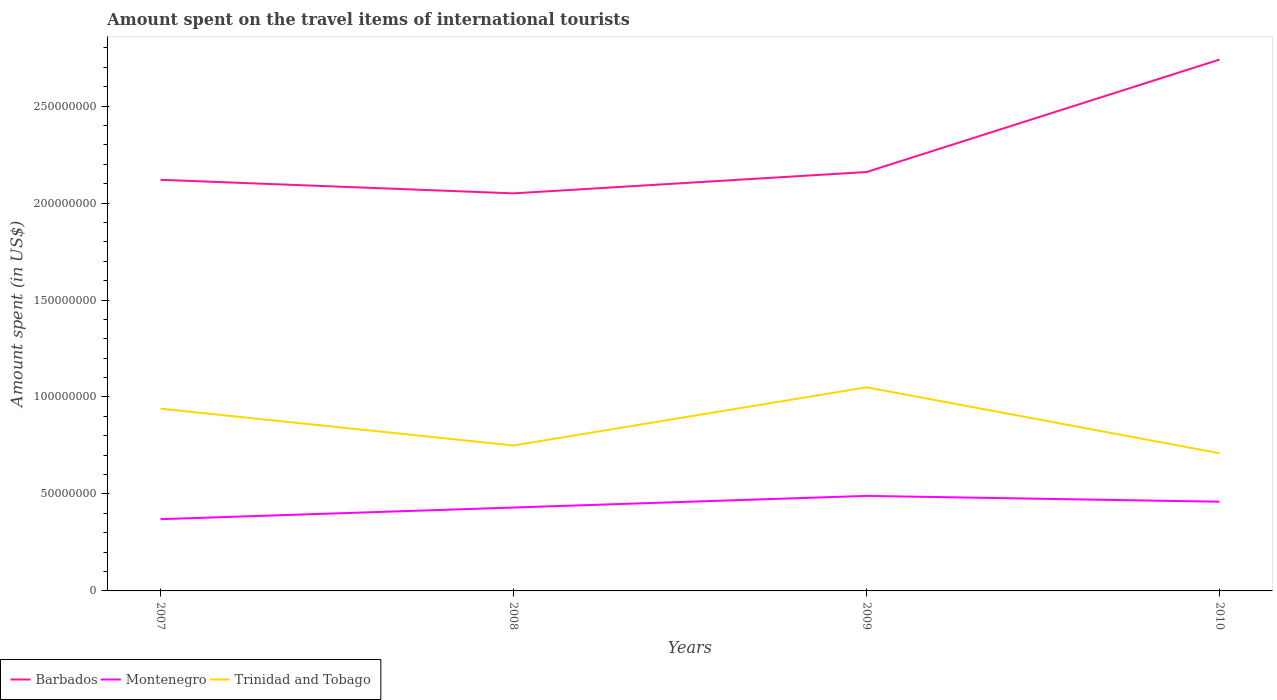How many different coloured lines are there?
Offer a terse response. 3. Does the line corresponding to Montenegro intersect with the line corresponding to Trinidad and Tobago?
Offer a terse response. No. Is the number of lines equal to the number of legend labels?
Your response must be concise. Yes. Across all years, what is the maximum amount spent on the travel items of international tourists in Montenegro?
Offer a terse response. 3.70e+07. What is the total amount spent on the travel items of international tourists in Barbados in the graph?
Your answer should be very brief. -6.90e+07. What is the difference between the highest and the second highest amount spent on the travel items of international tourists in Montenegro?
Offer a very short reply. 1.20e+07. What is the difference between the highest and the lowest amount spent on the travel items of international tourists in Montenegro?
Offer a very short reply. 2. What is the difference between two consecutive major ticks on the Y-axis?
Give a very brief answer. 5.00e+07. Are the values on the major ticks of Y-axis written in scientific E-notation?
Ensure brevity in your answer.  No. How many legend labels are there?
Your answer should be very brief. 3. What is the title of the graph?
Give a very brief answer. Amount spent on the travel items of international tourists. What is the label or title of the Y-axis?
Your answer should be very brief. Amount spent (in US$). What is the Amount spent (in US$) of Barbados in 2007?
Provide a short and direct response. 2.12e+08. What is the Amount spent (in US$) of Montenegro in 2007?
Provide a short and direct response. 3.70e+07. What is the Amount spent (in US$) of Trinidad and Tobago in 2007?
Offer a terse response. 9.40e+07. What is the Amount spent (in US$) of Barbados in 2008?
Your answer should be compact. 2.05e+08. What is the Amount spent (in US$) of Montenegro in 2008?
Your answer should be very brief. 4.30e+07. What is the Amount spent (in US$) in Trinidad and Tobago in 2008?
Provide a short and direct response. 7.50e+07. What is the Amount spent (in US$) in Barbados in 2009?
Provide a succinct answer. 2.16e+08. What is the Amount spent (in US$) of Montenegro in 2009?
Your answer should be very brief. 4.90e+07. What is the Amount spent (in US$) in Trinidad and Tobago in 2009?
Make the answer very short. 1.05e+08. What is the Amount spent (in US$) of Barbados in 2010?
Ensure brevity in your answer.  2.74e+08. What is the Amount spent (in US$) of Montenegro in 2010?
Keep it short and to the point. 4.60e+07. What is the Amount spent (in US$) of Trinidad and Tobago in 2010?
Make the answer very short. 7.10e+07. Across all years, what is the maximum Amount spent (in US$) in Barbados?
Provide a succinct answer. 2.74e+08. Across all years, what is the maximum Amount spent (in US$) in Montenegro?
Give a very brief answer. 4.90e+07. Across all years, what is the maximum Amount spent (in US$) in Trinidad and Tobago?
Give a very brief answer. 1.05e+08. Across all years, what is the minimum Amount spent (in US$) in Barbados?
Offer a terse response. 2.05e+08. Across all years, what is the minimum Amount spent (in US$) in Montenegro?
Ensure brevity in your answer.  3.70e+07. Across all years, what is the minimum Amount spent (in US$) of Trinidad and Tobago?
Offer a very short reply. 7.10e+07. What is the total Amount spent (in US$) of Barbados in the graph?
Ensure brevity in your answer.  9.07e+08. What is the total Amount spent (in US$) of Montenegro in the graph?
Give a very brief answer. 1.75e+08. What is the total Amount spent (in US$) in Trinidad and Tobago in the graph?
Give a very brief answer. 3.45e+08. What is the difference between the Amount spent (in US$) in Barbados in 2007 and that in 2008?
Your answer should be very brief. 7.00e+06. What is the difference between the Amount spent (in US$) of Montenegro in 2007 and that in 2008?
Give a very brief answer. -6.00e+06. What is the difference between the Amount spent (in US$) in Trinidad and Tobago in 2007 and that in 2008?
Keep it short and to the point. 1.90e+07. What is the difference between the Amount spent (in US$) of Barbados in 2007 and that in 2009?
Provide a succinct answer. -4.00e+06. What is the difference between the Amount spent (in US$) in Montenegro in 2007 and that in 2009?
Your answer should be very brief. -1.20e+07. What is the difference between the Amount spent (in US$) in Trinidad and Tobago in 2007 and that in 2009?
Keep it short and to the point. -1.10e+07. What is the difference between the Amount spent (in US$) of Barbados in 2007 and that in 2010?
Provide a succinct answer. -6.20e+07. What is the difference between the Amount spent (in US$) of Montenegro in 2007 and that in 2010?
Your answer should be very brief. -9.00e+06. What is the difference between the Amount spent (in US$) in Trinidad and Tobago in 2007 and that in 2010?
Your answer should be very brief. 2.30e+07. What is the difference between the Amount spent (in US$) of Barbados in 2008 and that in 2009?
Your answer should be compact. -1.10e+07. What is the difference between the Amount spent (in US$) in Montenegro in 2008 and that in 2009?
Give a very brief answer. -6.00e+06. What is the difference between the Amount spent (in US$) in Trinidad and Tobago in 2008 and that in 2009?
Make the answer very short. -3.00e+07. What is the difference between the Amount spent (in US$) of Barbados in 2008 and that in 2010?
Give a very brief answer. -6.90e+07. What is the difference between the Amount spent (in US$) of Barbados in 2009 and that in 2010?
Keep it short and to the point. -5.80e+07. What is the difference between the Amount spent (in US$) of Trinidad and Tobago in 2009 and that in 2010?
Provide a succinct answer. 3.40e+07. What is the difference between the Amount spent (in US$) in Barbados in 2007 and the Amount spent (in US$) in Montenegro in 2008?
Your answer should be compact. 1.69e+08. What is the difference between the Amount spent (in US$) of Barbados in 2007 and the Amount spent (in US$) of Trinidad and Tobago in 2008?
Make the answer very short. 1.37e+08. What is the difference between the Amount spent (in US$) of Montenegro in 2007 and the Amount spent (in US$) of Trinidad and Tobago in 2008?
Your response must be concise. -3.80e+07. What is the difference between the Amount spent (in US$) of Barbados in 2007 and the Amount spent (in US$) of Montenegro in 2009?
Offer a terse response. 1.63e+08. What is the difference between the Amount spent (in US$) in Barbados in 2007 and the Amount spent (in US$) in Trinidad and Tobago in 2009?
Give a very brief answer. 1.07e+08. What is the difference between the Amount spent (in US$) of Montenegro in 2007 and the Amount spent (in US$) of Trinidad and Tobago in 2009?
Ensure brevity in your answer.  -6.80e+07. What is the difference between the Amount spent (in US$) in Barbados in 2007 and the Amount spent (in US$) in Montenegro in 2010?
Offer a very short reply. 1.66e+08. What is the difference between the Amount spent (in US$) in Barbados in 2007 and the Amount spent (in US$) in Trinidad and Tobago in 2010?
Your answer should be very brief. 1.41e+08. What is the difference between the Amount spent (in US$) of Montenegro in 2007 and the Amount spent (in US$) of Trinidad and Tobago in 2010?
Provide a short and direct response. -3.40e+07. What is the difference between the Amount spent (in US$) of Barbados in 2008 and the Amount spent (in US$) of Montenegro in 2009?
Offer a very short reply. 1.56e+08. What is the difference between the Amount spent (in US$) in Barbados in 2008 and the Amount spent (in US$) in Trinidad and Tobago in 2009?
Give a very brief answer. 1.00e+08. What is the difference between the Amount spent (in US$) in Montenegro in 2008 and the Amount spent (in US$) in Trinidad and Tobago in 2009?
Offer a terse response. -6.20e+07. What is the difference between the Amount spent (in US$) in Barbados in 2008 and the Amount spent (in US$) in Montenegro in 2010?
Your answer should be compact. 1.59e+08. What is the difference between the Amount spent (in US$) of Barbados in 2008 and the Amount spent (in US$) of Trinidad and Tobago in 2010?
Keep it short and to the point. 1.34e+08. What is the difference between the Amount spent (in US$) in Montenegro in 2008 and the Amount spent (in US$) in Trinidad and Tobago in 2010?
Offer a terse response. -2.80e+07. What is the difference between the Amount spent (in US$) in Barbados in 2009 and the Amount spent (in US$) in Montenegro in 2010?
Your answer should be compact. 1.70e+08. What is the difference between the Amount spent (in US$) in Barbados in 2009 and the Amount spent (in US$) in Trinidad and Tobago in 2010?
Your answer should be compact. 1.45e+08. What is the difference between the Amount spent (in US$) in Montenegro in 2009 and the Amount spent (in US$) in Trinidad and Tobago in 2010?
Keep it short and to the point. -2.20e+07. What is the average Amount spent (in US$) in Barbados per year?
Keep it short and to the point. 2.27e+08. What is the average Amount spent (in US$) in Montenegro per year?
Ensure brevity in your answer.  4.38e+07. What is the average Amount spent (in US$) in Trinidad and Tobago per year?
Offer a very short reply. 8.62e+07. In the year 2007, what is the difference between the Amount spent (in US$) in Barbados and Amount spent (in US$) in Montenegro?
Provide a short and direct response. 1.75e+08. In the year 2007, what is the difference between the Amount spent (in US$) of Barbados and Amount spent (in US$) of Trinidad and Tobago?
Offer a terse response. 1.18e+08. In the year 2007, what is the difference between the Amount spent (in US$) of Montenegro and Amount spent (in US$) of Trinidad and Tobago?
Ensure brevity in your answer.  -5.70e+07. In the year 2008, what is the difference between the Amount spent (in US$) of Barbados and Amount spent (in US$) of Montenegro?
Make the answer very short. 1.62e+08. In the year 2008, what is the difference between the Amount spent (in US$) in Barbados and Amount spent (in US$) in Trinidad and Tobago?
Make the answer very short. 1.30e+08. In the year 2008, what is the difference between the Amount spent (in US$) in Montenegro and Amount spent (in US$) in Trinidad and Tobago?
Keep it short and to the point. -3.20e+07. In the year 2009, what is the difference between the Amount spent (in US$) of Barbados and Amount spent (in US$) of Montenegro?
Keep it short and to the point. 1.67e+08. In the year 2009, what is the difference between the Amount spent (in US$) of Barbados and Amount spent (in US$) of Trinidad and Tobago?
Offer a terse response. 1.11e+08. In the year 2009, what is the difference between the Amount spent (in US$) of Montenegro and Amount spent (in US$) of Trinidad and Tobago?
Give a very brief answer. -5.60e+07. In the year 2010, what is the difference between the Amount spent (in US$) in Barbados and Amount spent (in US$) in Montenegro?
Offer a very short reply. 2.28e+08. In the year 2010, what is the difference between the Amount spent (in US$) of Barbados and Amount spent (in US$) of Trinidad and Tobago?
Provide a succinct answer. 2.03e+08. In the year 2010, what is the difference between the Amount spent (in US$) in Montenegro and Amount spent (in US$) in Trinidad and Tobago?
Make the answer very short. -2.50e+07. What is the ratio of the Amount spent (in US$) of Barbados in 2007 to that in 2008?
Offer a terse response. 1.03. What is the ratio of the Amount spent (in US$) in Montenegro in 2007 to that in 2008?
Keep it short and to the point. 0.86. What is the ratio of the Amount spent (in US$) of Trinidad and Tobago in 2007 to that in 2008?
Your answer should be very brief. 1.25. What is the ratio of the Amount spent (in US$) of Barbados in 2007 to that in 2009?
Provide a succinct answer. 0.98. What is the ratio of the Amount spent (in US$) of Montenegro in 2007 to that in 2009?
Provide a short and direct response. 0.76. What is the ratio of the Amount spent (in US$) in Trinidad and Tobago in 2007 to that in 2009?
Ensure brevity in your answer.  0.9. What is the ratio of the Amount spent (in US$) of Barbados in 2007 to that in 2010?
Give a very brief answer. 0.77. What is the ratio of the Amount spent (in US$) in Montenegro in 2007 to that in 2010?
Offer a very short reply. 0.8. What is the ratio of the Amount spent (in US$) in Trinidad and Tobago in 2007 to that in 2010?
Offer a very short reply. 1.32. What is the ratio of the Amount spent (in US$) of Barbados in 2008 to that in 2009?
Offer a terse response. 0.95. What is the ratio of the Amount spent (in US$) in Montenegro in 2008 to that in 2009?
Make the answer very short. 0.88. What is the ratio of the Amount spent (in US$) in Trinidad and Tobago in 2008 to that in 2009?
Keep it short and to the point. 0.71. What is the ratio of the Amount spent (in US$) of Barbados in 2008 to that in 2010?
Provide a succinct answer. 0.75. What is the ratio of the Amount spent (in US$) of Montenegro in 2008 to that in 2010?
Ensure brevity in your answer.  0.93. What is the ratio of the Amount spent (in US$) of Trinidad and Tobago in 2008 to that in 2010?
Provide a short and direct response. 1.06. What is the ratio of the Amount spent (in US$) in Barbados in 2009 to that in 2010?
Your answer should be very brief. 0.79. What is the ratio of the Amount spent (in US$) of Montenegro in 2009 to that in 2010?
Your answer should be very brief. 1.07. What is the ratio of the Amount spent (in US$) in Trinidad and Tobago in 2009 to that in 2010?
Make the answer very short. 1.48. What is the difference between the highest and the second highest Amount spent (in US$) of Barbados?
Provide a short and direct response. 5.80e+07. What is the difference between the highest and the second highest Amount spent (in US$) in Montenegro?
Give a very brief answer. 3.00e+06. What is the difference between the highest and the second highest Amount spent (in US$) in Trinidad and Tobago?
Your answer should be compact. 1.10e+07. What is the difference between the highest and the lowest Amount spent (in US$) in Barbados?
Your answer should be compact. 6.90e+07. What is the difference between the highest and the lowest Amount spent (in US$) of Montenegro?
Your answer should be compact. 1.20e+07. What is the difference between the highest and the lowest Amount spent (in US$) in Trinidad and Tobago?
Your answer should be very brief. 3.40e+07. 